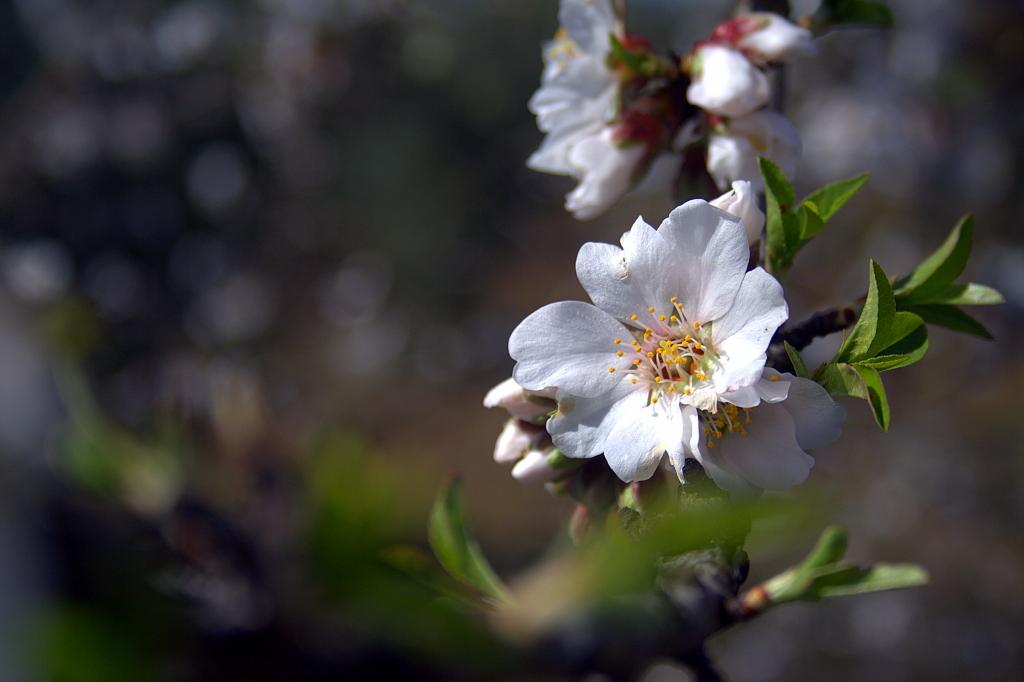What is the main subject of the image? The main subject of the image is a tree. How is the tree depicted in the image? The tree is truncated in the image. Are there any additional features on the tree? Yes, there are flowers on the tree. Can you describe the background of the image? The background of the image is blurred. Is there any iron visible in the image? There is no iron present in the image; it features a tree with flowers and a blurred background. 